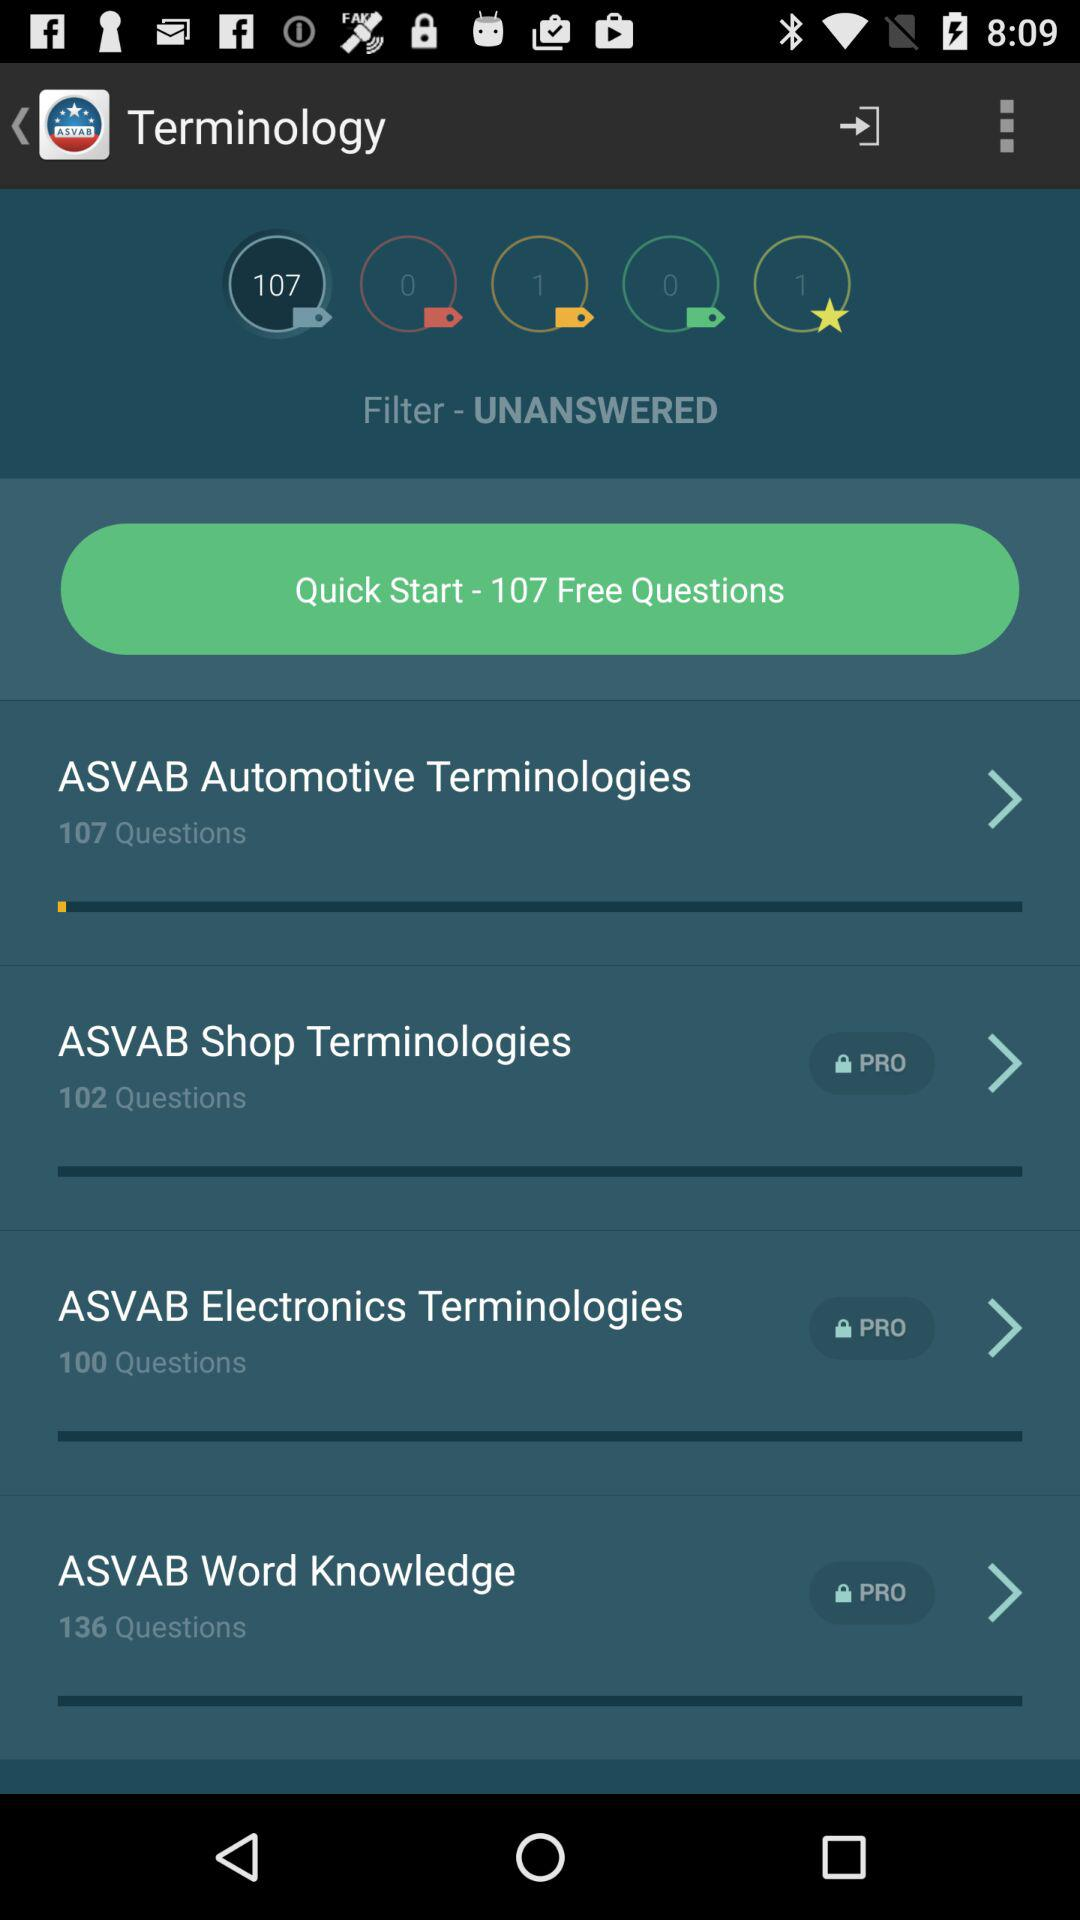How many questions are there in ASVAB Automotive Terminologies?
Answer the question using a single word or phrase. 107 